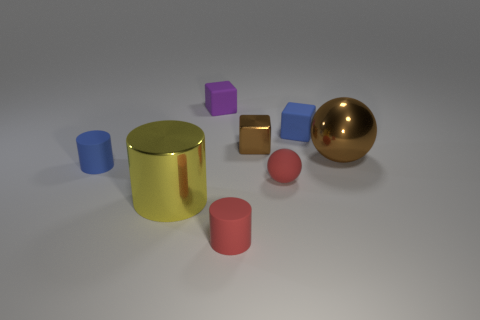Is the number of purple rubber blocks right of the big yellow metal cylinder less than the number of tiny metal cubes that are in front of the small rubber sphere?
Your response must be concise. No. There is a big brown object that is made of the same material as the yellow cylinder; what is its shape?
Offer a very short reply. Sphere. There is a blue thing behind the tiny rubber cylinder on the left side of the big shiny object to the left of the small red matte ball; what size is it?
Offer a very short reply. Small. Is the number of large things greater than the number of small brown metallic objects?
Your answer should be very brief. Yes. Does the tiny cylinder that is to the left of the purple block have the same color as the tiny matte cube that is on the left side of the blue rubber cube?
Offer a terse response. No. Does the big object right of the small purple cube have the same material as the tiny blue thing that is left of the metallic cylinder?
Give a very brief answer. No. How many metallic spheres are the same size as the matte sphere?
Your response must be concise. 0. Is the number of large yellow things less than the number of small rubber things?
Offer a terse response. Yes. The red object behind the red thing in front of the large shiny cylinder is what shape?
Keep it short and to the point. Sphere. There is a red rubber thing that is the same size as the red sphere; what is its shape?
Your response must be concise. Cylinder. 